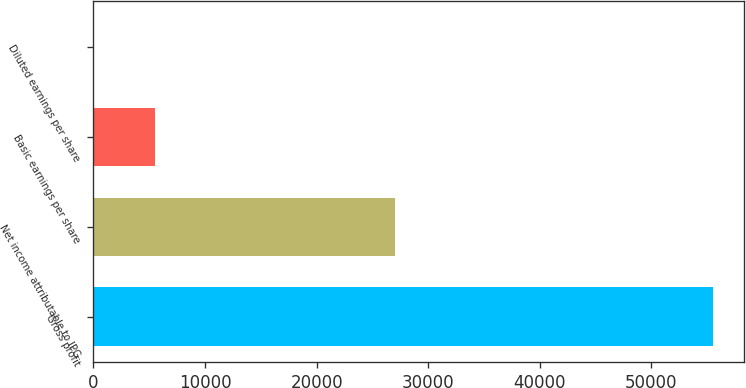Convert chart. <chart><loc_0><loc_0><loc_500><loc_500><bar_chart><fcel>Gross profit<fcel>Net income attributable to IPG<fcel>Basic earnings per share<fcel>Diluted earnings per share<nl><fcel>55519<fcel>27062<fcel>5552.4<fcel>0.56<nl></chart> 